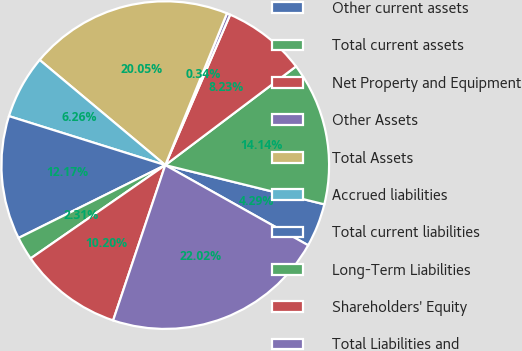<chart> <loc_0><loc_0><loc_500><loc_500><pie_chart><fcel>Other current assets<fcel>Total current assets<fcel>Net Property and Equipment<fcel>Other Assets<fcel>Total Assets<fcel>Accrued liabilities<fcel>Total current liabilities<fcel>Long-Term Liabilities<fcel>Shareholders' Equity<fcel>Total Liabilities and<nl><fcel>4.29%<fcel>14.14%<fcel>8.23%<fcel>0.34%<fcel>20.05%<fcel>6.26%<fcel>12.17%<fcel>2.31%<fcel>10.2%<fcel>22.02%<nl></chart> 